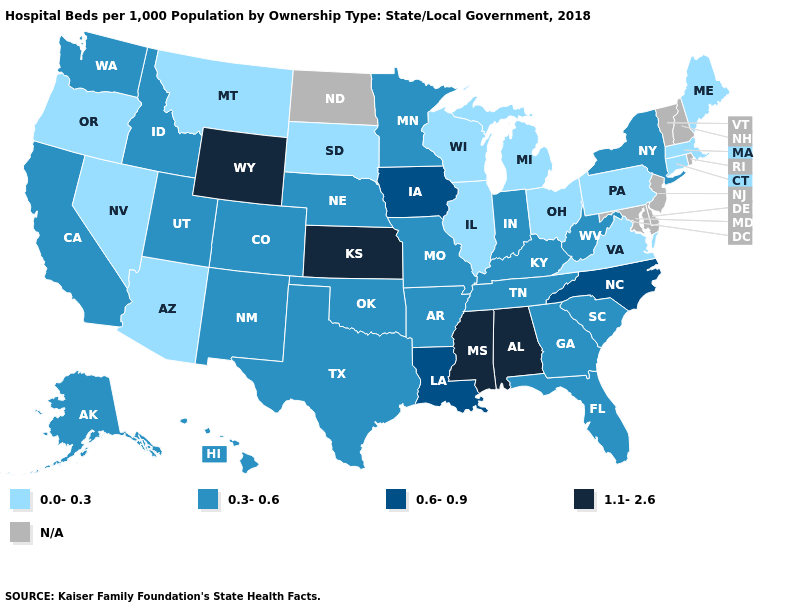What is the highest value in the Northeast ?
Keep it brief. 0.3-0.6. Name the states that have a value in the range 1.1-2.6?
Be succinct. Alabama, Kansas, Mississippi, Wyoming. Which states have the highest value in the USA?
Concise answer only. Alabama, Kansas, Mississippi, Wyoming. Does Kansas have the highest value in the MidWest?
Short answer required. Yes. Which states have the lowest value in the USA?
Concise answer only. Arizona, Connecticut, Illinois, Maine, Massachusetts, Michigan, Montana, Nevada, Ohio, Oregon, Pennsylvania, South Dakota, Virginia, Wisconsin. Name the states that have a value in the range N/A?
Be succinct. Delaware, Maryland, New Hampshire, New Jersey, North Dakota, Rhode Island, Vermont. What is the highest value in the USA?
Short answer required. 1.1-2.6. What is the value of Michigan?
Write a very short answer. 0.0-0.3. Does the map have missing data?
Short answer required. Yes. Among the states that border Washington , which have the highest value?
Be succinct. Idaho. What is the lowest value in the USA?
Concise answer only. 0.0-0.3. Name the states that have a value in the range 1.1-2.6?
Short answer required. Alabama, Kansas, Mississippi, Wyoming. What is the lowest value in the USA?
Short answer required. 0.0-0.3. What is the highest value in states that border Georgia?
Answer briefly. 1.1-2.6. 